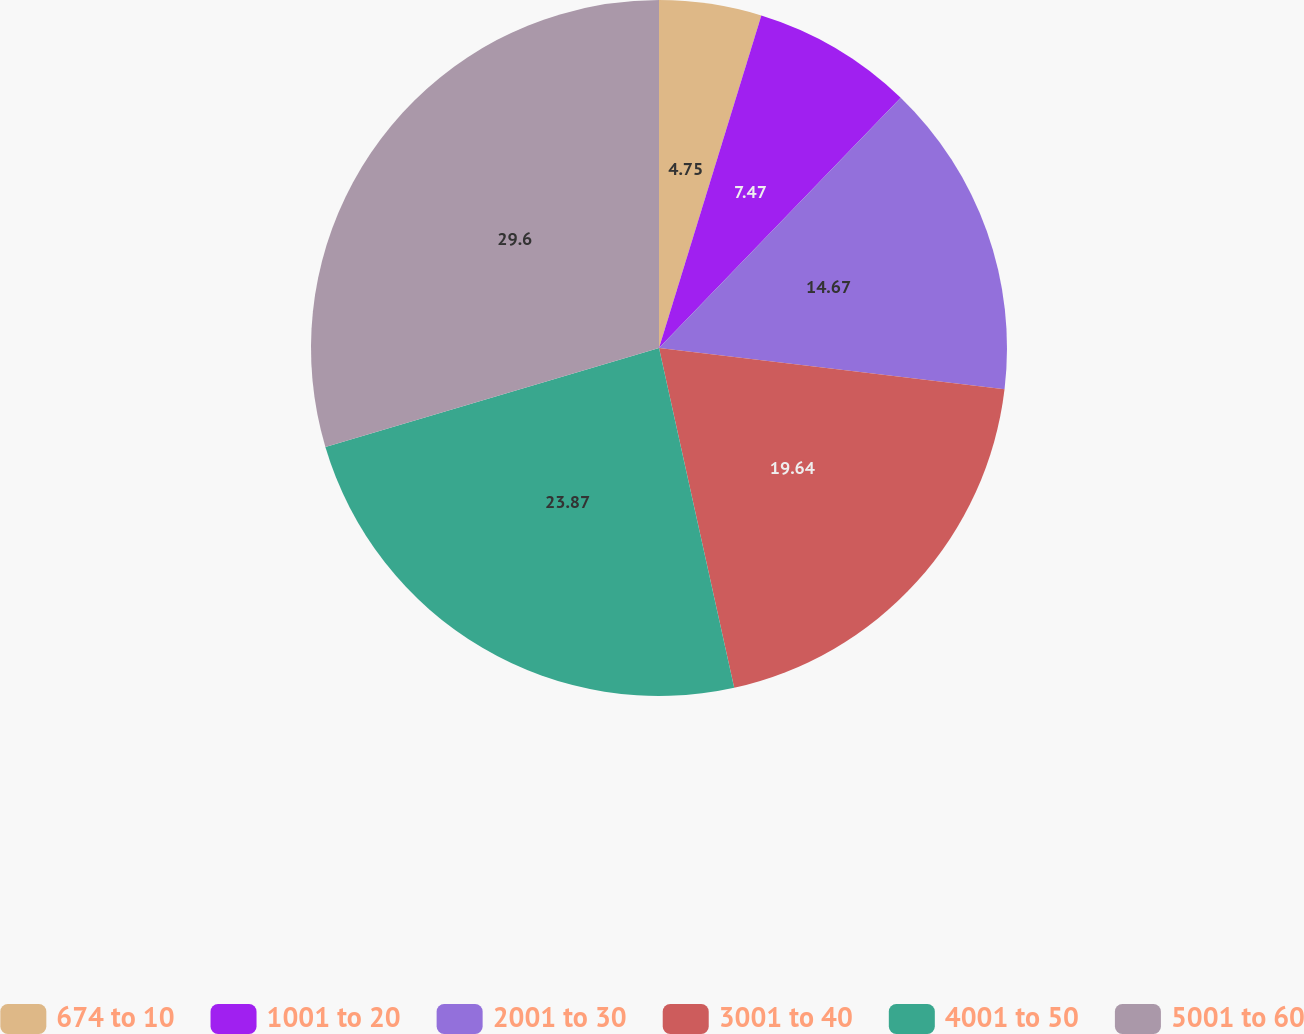<chart> <loc_0><loc_0><loc_500><loc_500><pie_chart><fcel>674 to 10<fcel>1001 to 20<fcel>2001 to 30<fcel>3001 to 40<fcel>4001 to 50<fcel>5001 to 60<nl><fcel>4.75%<fcel>7.47%<fcel>14.67%<fcel>19.64%<fcel>23.87%<fcel>29.59%<nl></chart> 